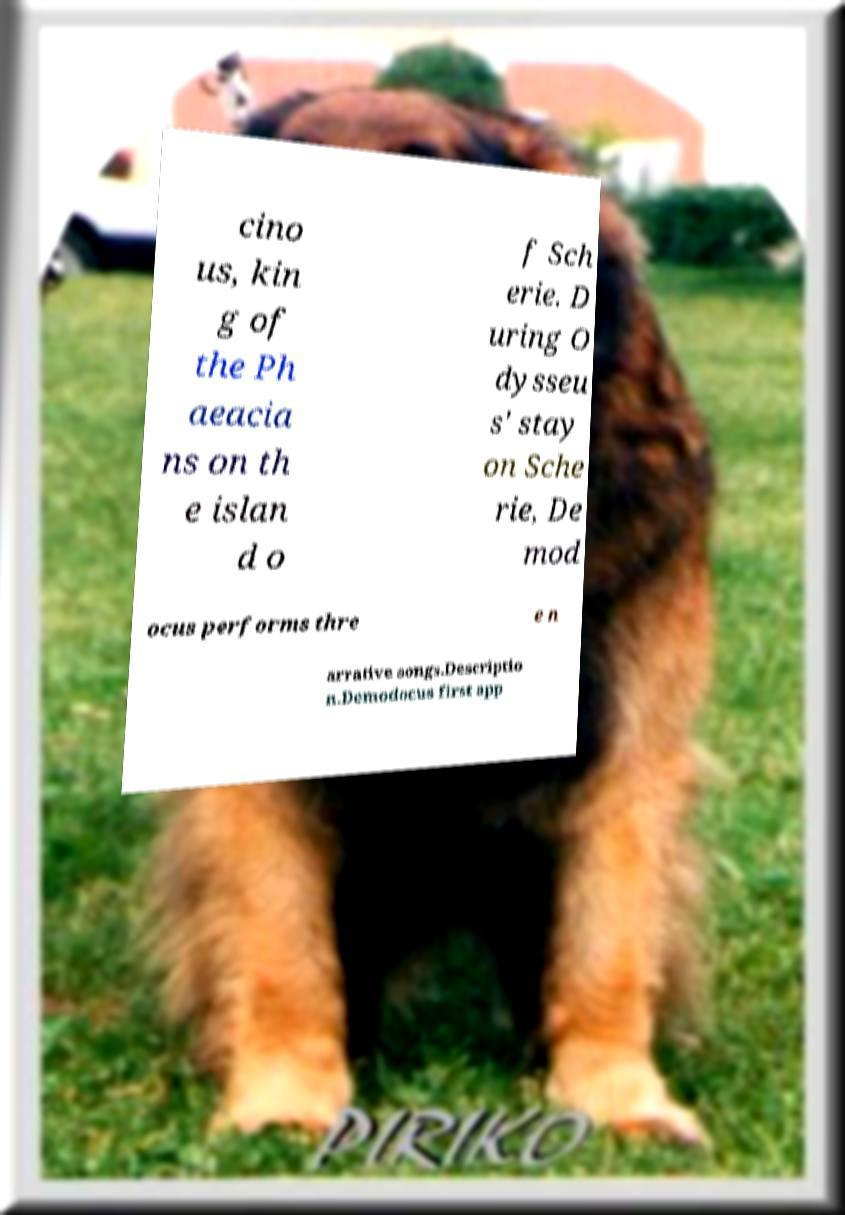There's text embedded in this image that I need extracted. Can you transcribe it verbatim? cino us, kin g of the Ph aeacia ns on th e islan d o f Sch erie. D uring O dysseu s' stay on Sche rie, De mod ocus performs thre e n arrative songs.Descriptio n.Demodocus first app 